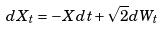Convert formula to latex. <formula><loc_0><loc_0><loc_500><loc_500>d X _ { t } = - X d t + \sqrt { 2 } d W _ { t }</formula> 